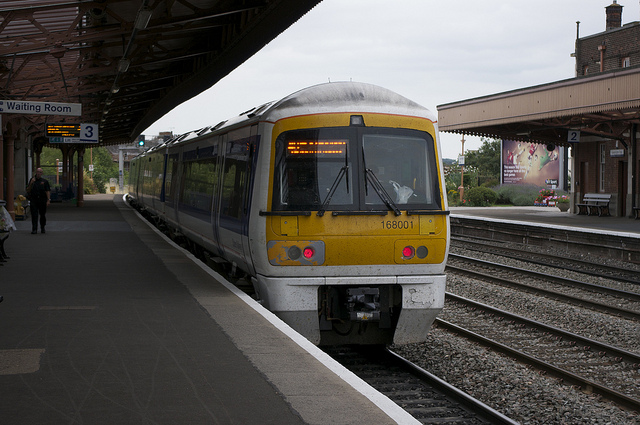Identify the text contained in this image. 168001 3 Waiting Room 2 